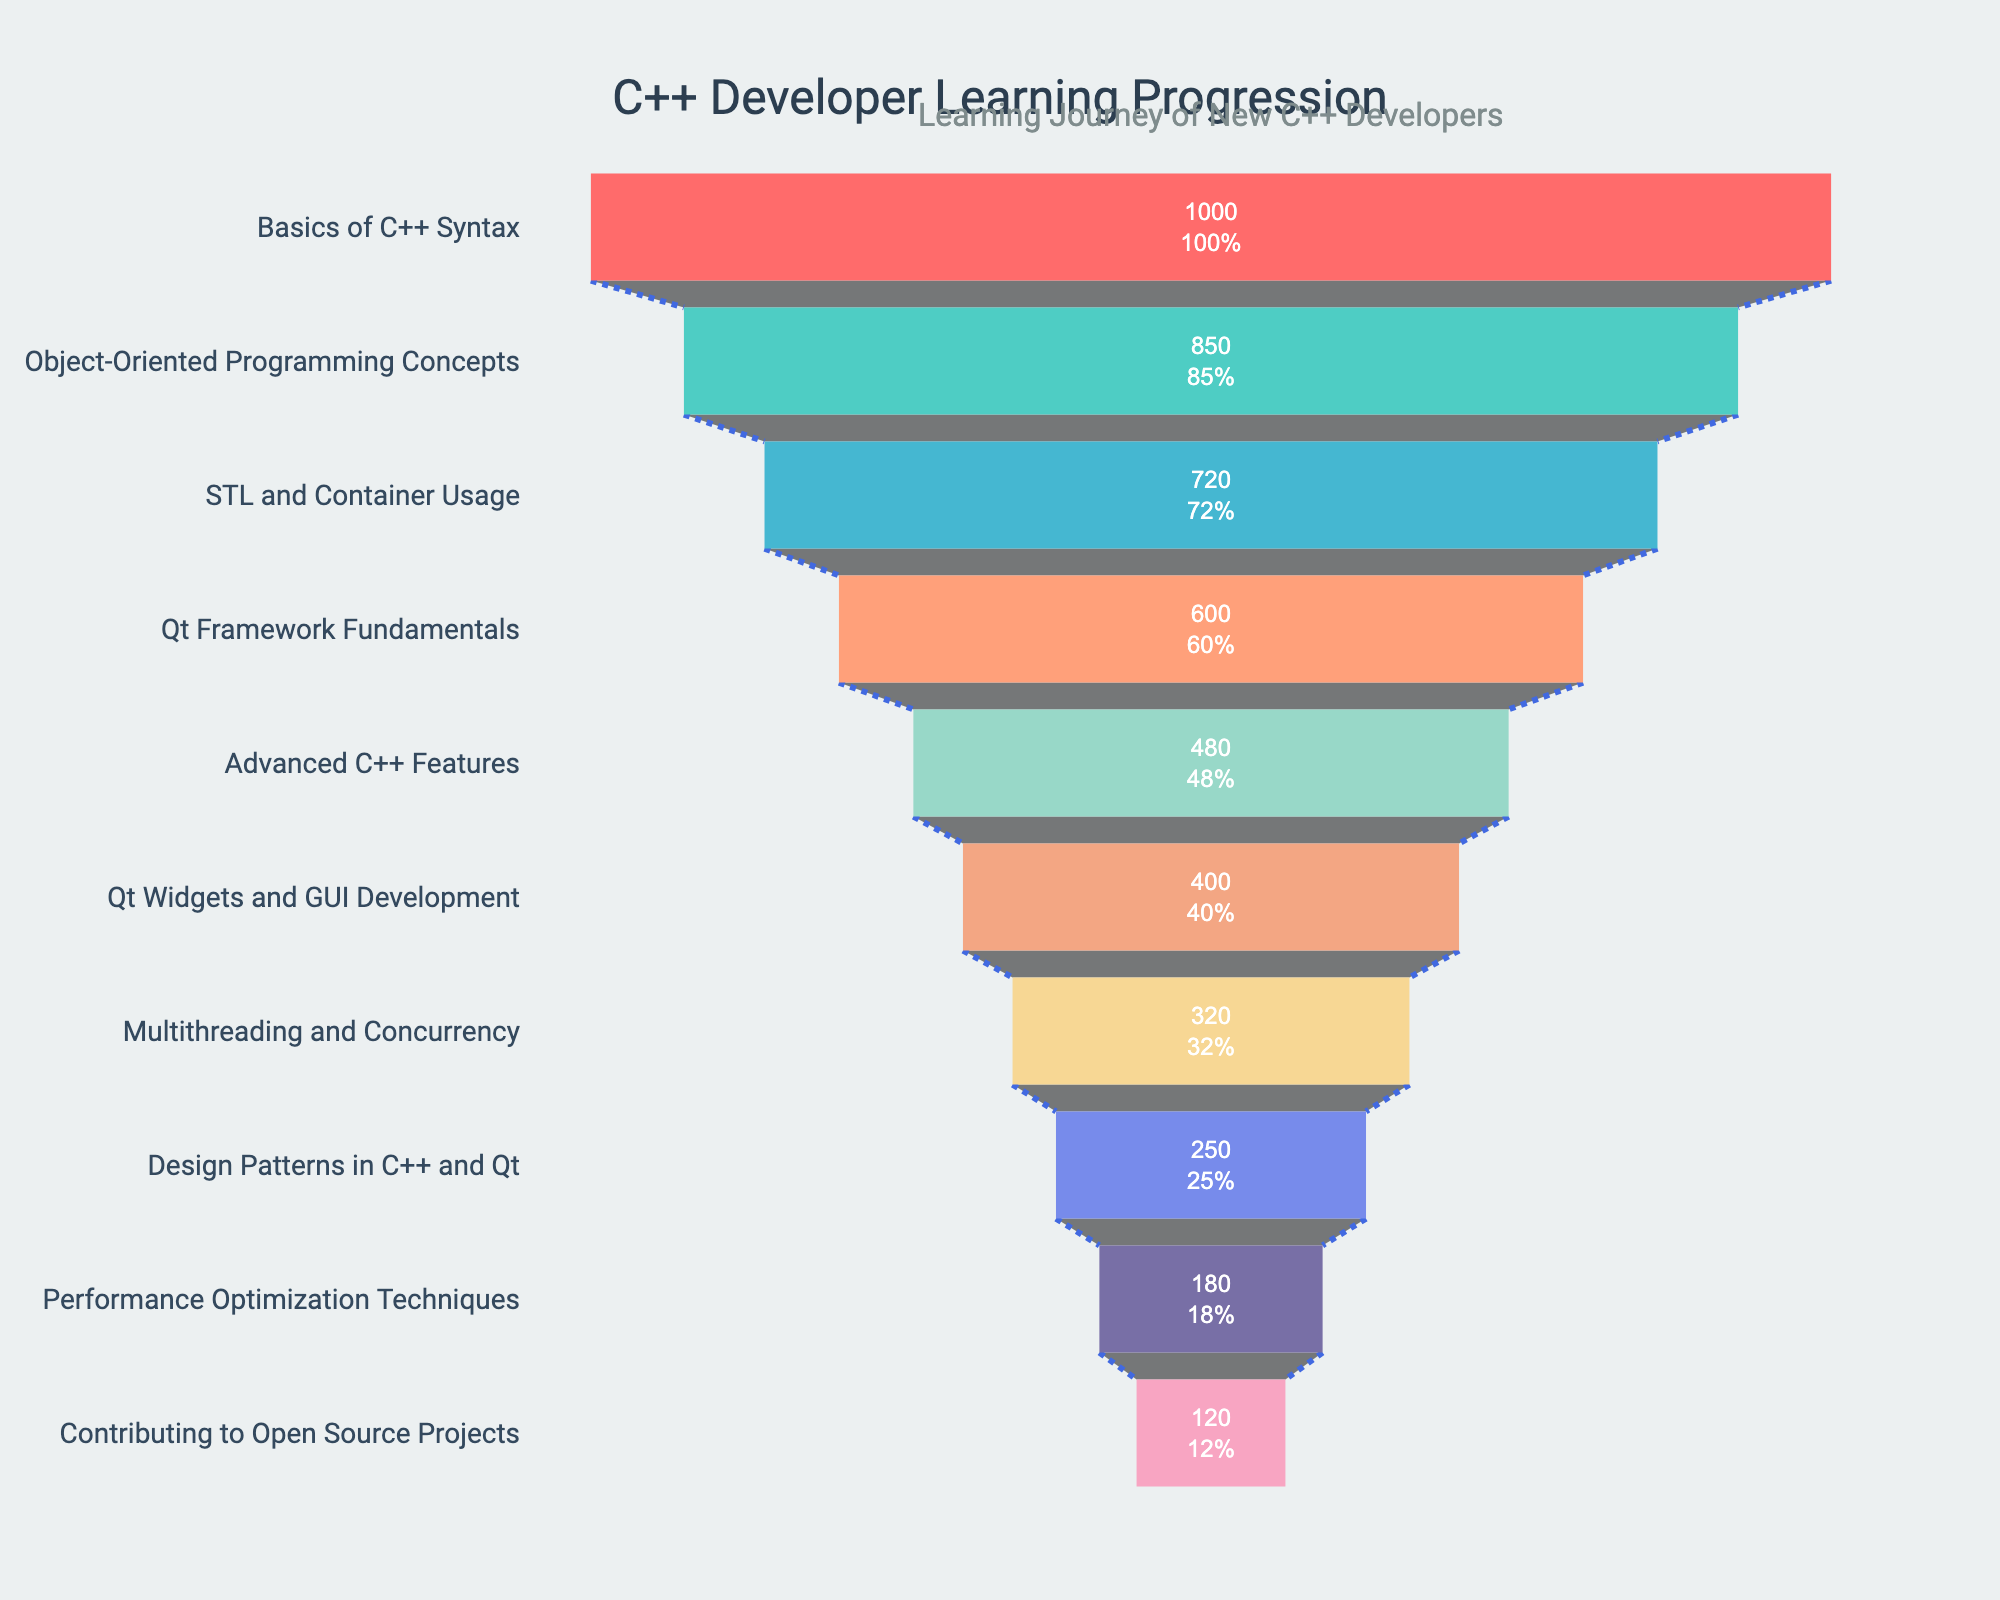what is the title of the figure? The title is usually displayed at the top of the chart in bold or larger font. In this case, it can be found in the center of the top of the figure.
Answer: 'C++ Developer Learning Progression' How many stages are depicted in the funnel chart? To figure out the number of stages, you can count all distinct entries on the Y-axis.
Answer: 10 Which stage has the greatest number of developers? To identify this, look for the stage with the largest bar or the highest value on the X-axis.
Answer: Basics of C++ Syntax At which stage do the developers first fall below 500? Identify the stages on the Y-axis and check where the developer count first goes below 500.
Answer: Qt Framework Fundamentals How many developers reach the final stage? The final stage is at the bottom of the funnel. Identify the developer count in this last stage.
Answer: 120 What percentage of developers transition from Basics of C++ Syntax to Object-Oriented Programming Concepts? Calculate the percentage by dividing the number of developers at the Object-Oriented Programming Concepts stage by the number at the Basics of C++ Syntax stage and then multiply by 100.
Answer: 85% Compare the drop from Qt Widgets and GUI Development to Multithreading and Concurrency with the drop from STL and Container Usage to Qt Framework Fundamentals. Which is greater? Determine the difference in developers between the two stages for both transitions and compare the absolute values.
Answer: Drop between Qt Widgets and GUI Development to Multithreading and Concurrency (400 to 320) is less than the drop between STL and Container Usage to Qt Framework Fundamentals (720 to 600) What is the second largest stage in terms of developer count? Look at the bars on the funnel chart and identify the second highest bar value.
Answer: Object-Oriented Programming Concepts Calculate the average number of developers per stage. Sum all the developer counts and then divide by the number of stages.
Answer: \( \frac{4420}{10} \) = 442 What are the two stages with the closest number of developers? Identify the developer counts for all stages and find the two stages with the smallest absolute difference in their values.
Answer: Multithreading and Concurrency (320) and Design Patterns in C++ and Qt (250), difference of 70 